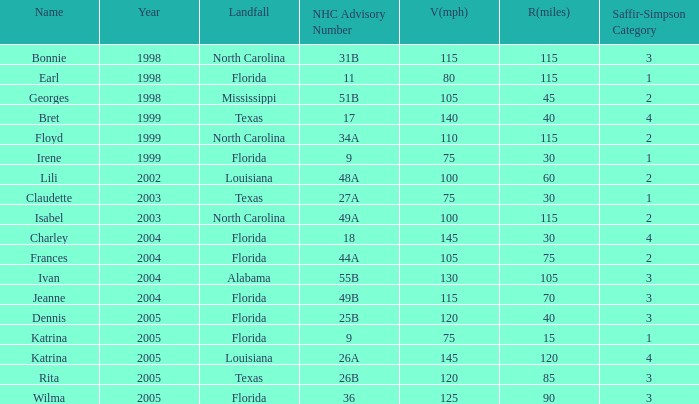What was the lowest V(mph) for a Saffir-Simpson of 4 in 2005? 145.0. 